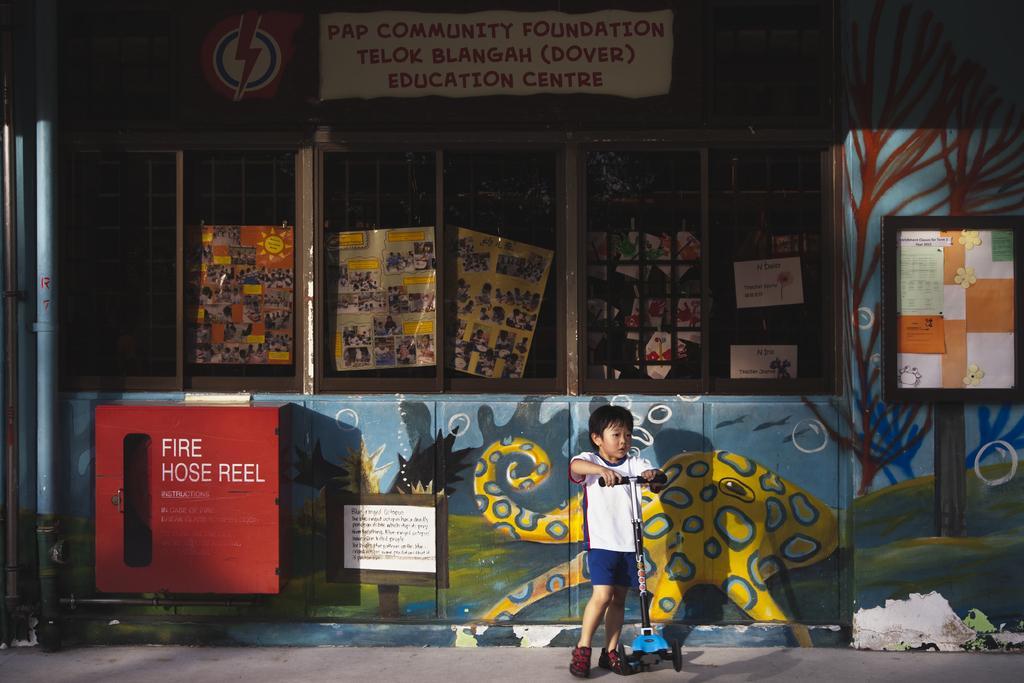Describe this image in one or two sentences. In the center of the image, we can see a boy holding skating wheel and in the background, we can see a building and some boards which are placed on the wall. At the bottom, there is road. 